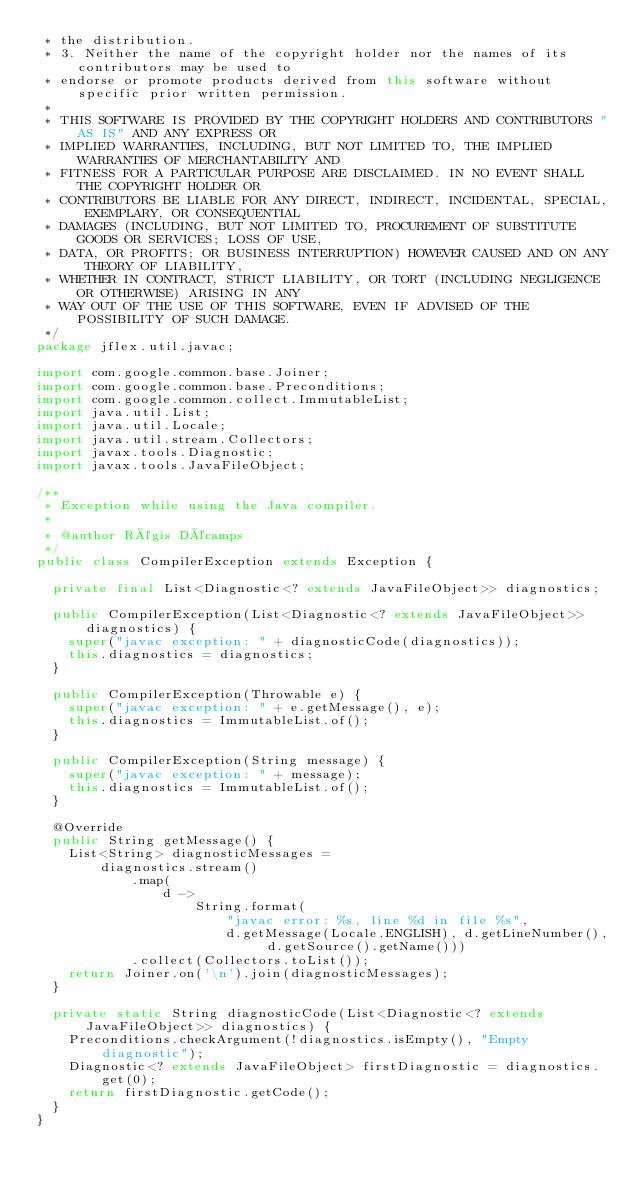<code> <loc_0><loc_0><loc_500><loc_500><_Java_> * the distribution.
 * 3. Neither the name of the copyright holder nor the names of its contributors may be used to
 * endorse or promote products derived from this software without specific prior written permission.
 *
 * THIS SOFTWARE IS PROVIDED BY THE COPYRIGHT HOLDERS AND CONTRIBUTORS "AS IS" AND ANY EXPRESS OR
 * IMPLIED WARRANTIES, INCLUDING, BUT NOT LIMITED TO, THE IMPLIED WARRANTIES OF MERCHANTABILITY AND
 * FITNESS FOR A PARTICULAR PURPOSE ARE DISCLAIMED. IN NO EVENT SHALL THE COPYRIGHT HOLDER OR
 * CONTRIBUTORS BE LIABLE FOR ANY DIRECT, INDIRECT, INCIDENTAL, SPECIAL, EXEMPLARY, OR CONSEQUENTIAL
 * DAMAGES (INCLUDING, BUT NOT LIMITED TO, PROCUREMENT OF SUBSTITUTE GOODS OR SERVICES; LOSS OF USE,
 * DATA, OR PROFITS; OR BUSINESS INTERRUPTION) HOWEVER CAUSED AND ON ANY THEORY OF LIABILITY,
 * WHETHER IN CONTRACT, STRICT LIABILITY, OR TORT (INCLUDING NEGLIGENCE OR OTHERWISE) ARISING IN ANY
 * WAY OUT OF THE USE OF THIS SOFTWARE, EVEN IF ADVISED OF THE POSSIBILITY OF SUCH DAMAGE.
 */
package jflex.util.javac;

import com.google.common.base.Joiner;
import com.google.common.base.Preconditions;
import com.google.common.collect.ImmutableList;
import java.util.List;
import java.util.Locale;
import java.util.stream.Collectors;
import javax.tools.Diagnostic;
import javax.tools.JavaFileObject;

/**
 * Exception while using the Java compiler.
 *
 * @author Régis Décamps
 */
public class CompilerException extends Exception {

  private final List<Diagnostic<? extends JavaFileObject>> diagnostics;

  public CompilerException(List<Diagnostic<? extends JavaFileObject>> diagnostics) {
    super("javac exception: " + diagnosticCode(diagnostics));
    this.diagnostics = diagnostics;
  }

  public CompilerException(Throwable e) {
    super("javac exception: " + e.getMessage(), e);
    this.diagnostics = ImmutableList.of();
  }

  public CompilerException(String message) {
    super("javac exception: " + message);
    this.diagnostics = ImmutableList.of();
  }

  @Override
  public String getMessage() {
    List<String> diagnosticMessages =
        diagnostics.stream()
            .map(
                d ->
                    String.format(
                        "javac error: %s, line %d in file %s",
                        d.getMessage(Locale.ENGLISH), d.getLineNumber(), d.getSource().getName()))
            .collect(Collectors.toList());
    return Joiner.on('\n').join(diagnosticMessages);
  }

  private static String diagnosticCode(List<Diagnostic<? extends JavaFileObject>> diagnostics) {
    Preconditions.checkArgument(!diagnostics.isEmpty(), "Empty diagnostic");
    Diagnostic<? extends JavaFileObject> firstDiagnostic = diagnostics.get(0);
    return firstDiagnostic.getCode();
  }
}
</code> 